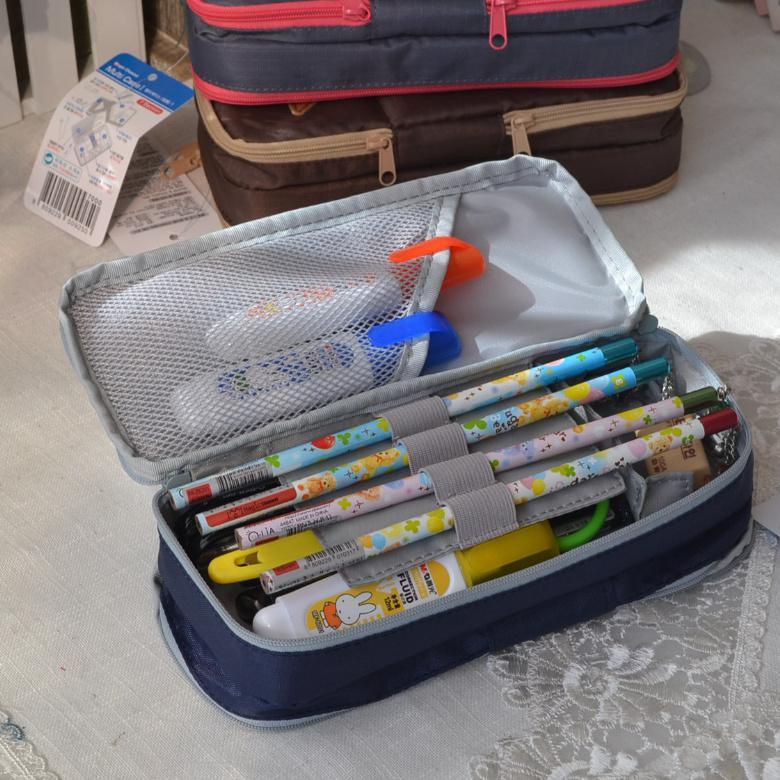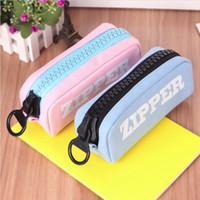The first image is the image on the left, the second image is the image on the right. For the images shown, is this caption "Left image shows an open blue case filled with writing supplies." true? Answer yes or no. Yes. The first image is the image on the left, the second image is the image on the right. Analyze the images presented: Is the assertion "The bags in one of the images are decorated with words." valid? Answer yes or no. Yes. 